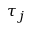<formula> <loc_0><loc_0><loc_500><loc_500>\tau _ { j }</formula> 